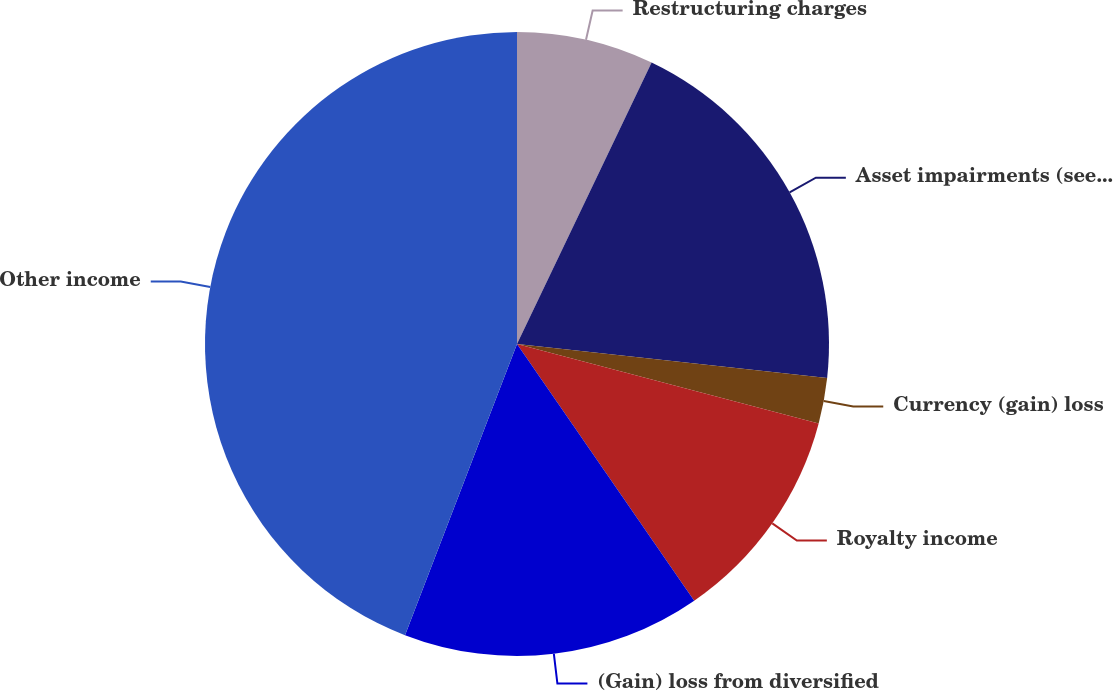<chart> <loc_0><loc_0><loc_500><loc_500><pie_chart><fcel>Restructuring charges<fcel>Asset impairments (see Note C)<fcel>Currency (gain) loss<fcel>Royalty income<fcel>(Gain) loss from diversified<fcel>Other income<nl><fcel>7.1%<fcel>19.64%<fcel>2.37%<fcel>11.28%<fcel>15.46%<fcel>44.16%<nl></chart> 